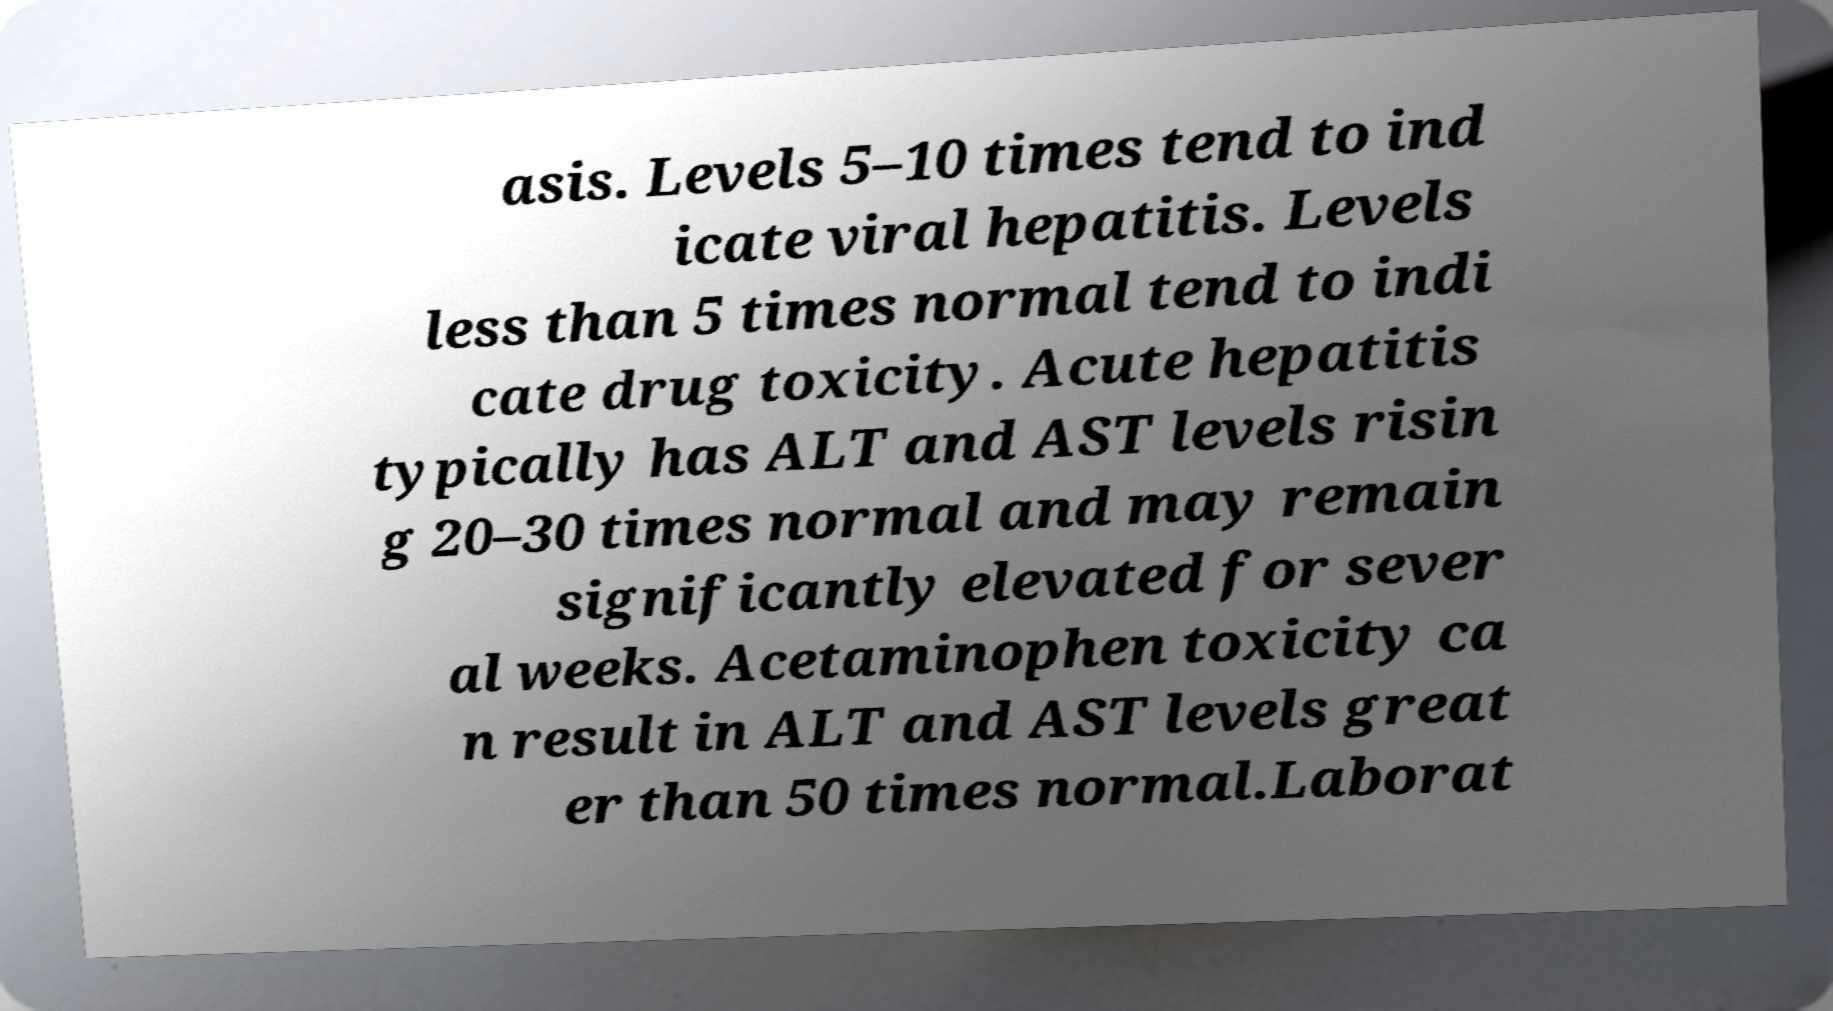Could you extract and type out the text from this image? asis. Levels 5–10 times tend to ind icate viral hepatitis. Levels less than 5 times normal tend to indi cate drug toxicity. Acute hepatitis typically has ALT and AST levels risin g 20–30 times normal and may remain significantly elevated for sever al weeks. Acetaminophen toxicity ca n result in ALT and AST levels great er than 50 times normal.Laborat 